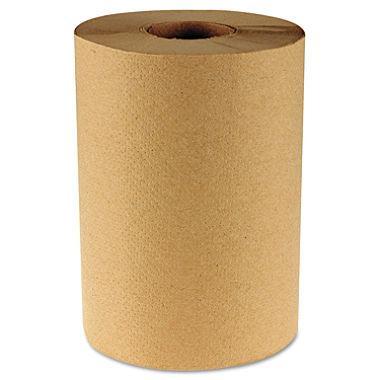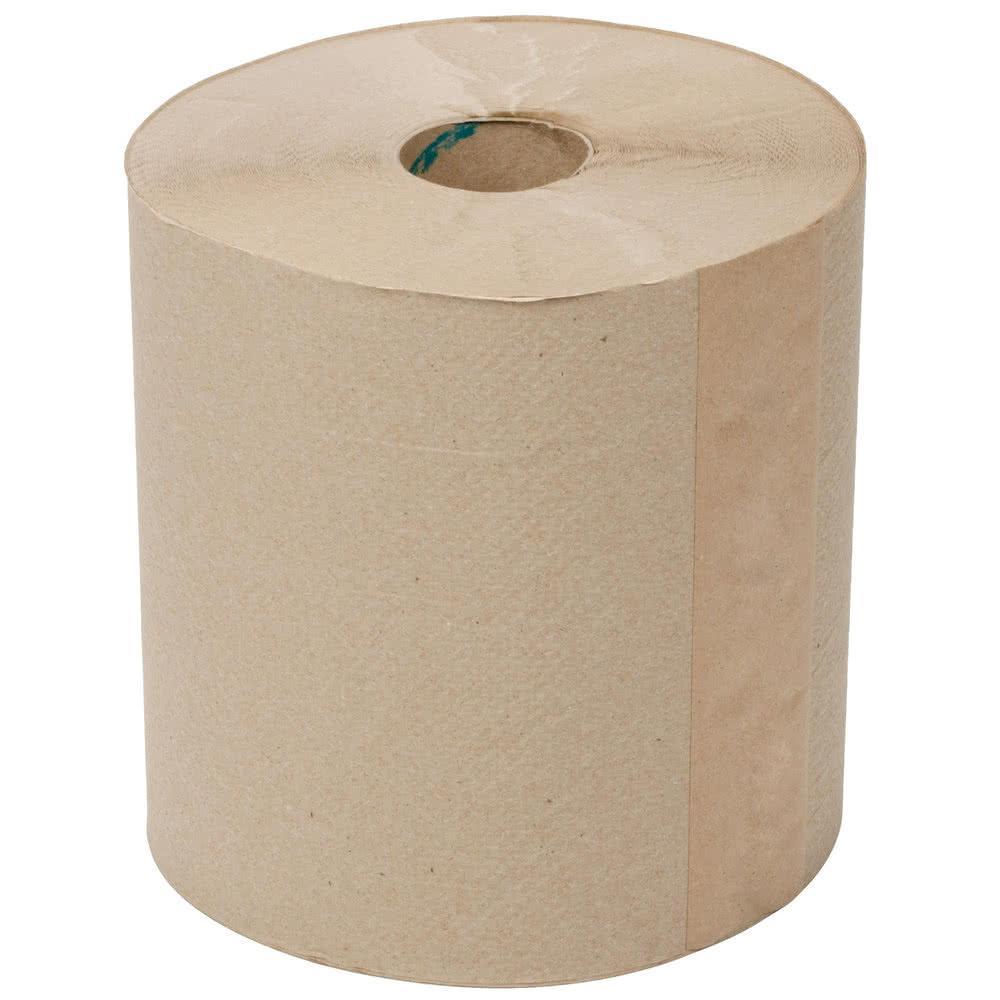The first image is the image on the left, the second image is the image on the right. For the images shown, is this caption "There are two paper towel rolls" true? Answer yes or no. Yes. The first image is the image on the left, the second image is the image on the right. Examine the images to the left and right. Is the description "The roll of brown paper in the image on the right is partially unrolled." accurate? Answer yes or no. No. 